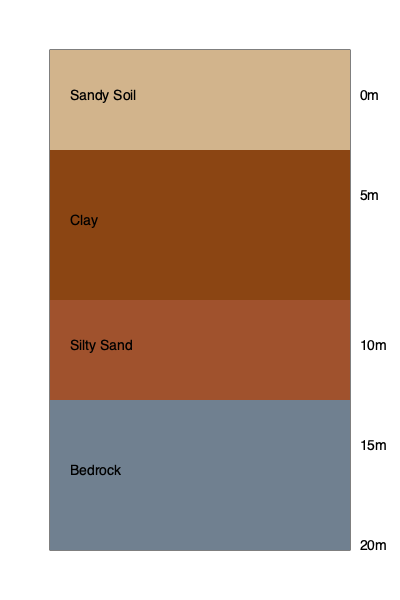Based on the borehole log diagram, at what depth does the bedrock layer begin? To determine the depth at which the bedrock layer begins, we need to analyze the soil stratification layers shown in the borehole log diagram. Let's go through the layers from top to bottom:

1. The topmost layer (light brown) is labeled as Sandy Soil, extending from 0m to 5m depth.
2. The second layer (dark brown) is Clay, stretching from 5m to 10m depth.
3. The third layer (medium brown) is Silty Sand, ranging from 10m to 15m depth.
4. The bottom layer (gray) is labeled as Bedrock.

By examining the depth labels on the right side of the diagram, we can see that the Bedrock layer starts at the 15m mark.

Therefore, the bedrock layer begins at a depth of 15 meters from the surface.
Answer: 15 meters 